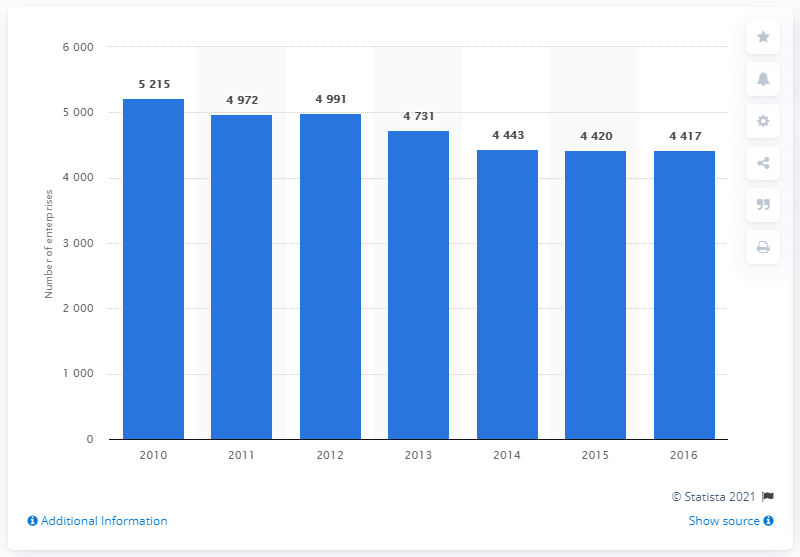Specify some key components in this picture. There were 4,417 travel agency and tour operator enterprises in the UK in 2016. 